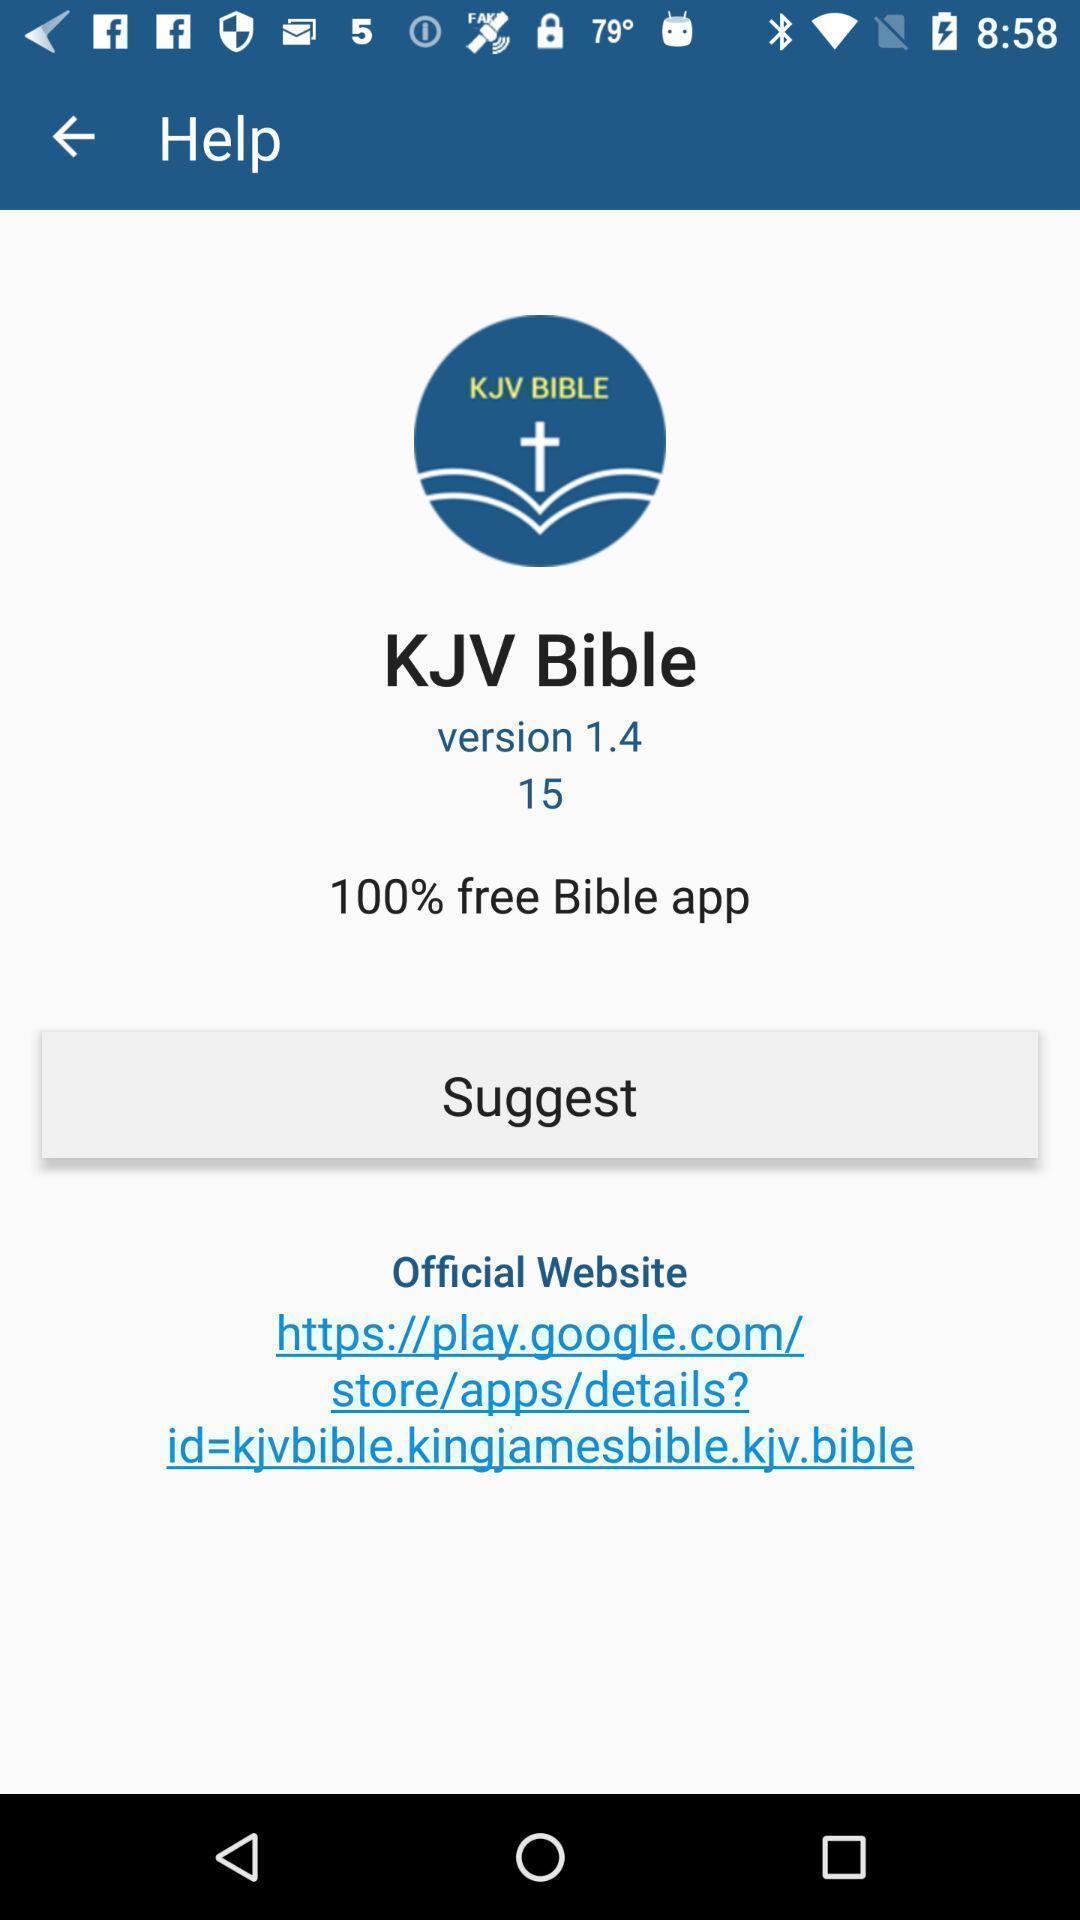Give me a narrative description of this picture. Screen showing help page. 